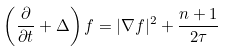Convert formula to latex. <formula><loc_0><loc_0><loc_500><loc_500>\left ( \frac { \partial } { \partial t } + \Delta \right ) f = | \nabla f | ^ { 2 } + \frac { n + 1 } { 2 \tau }</formula> 